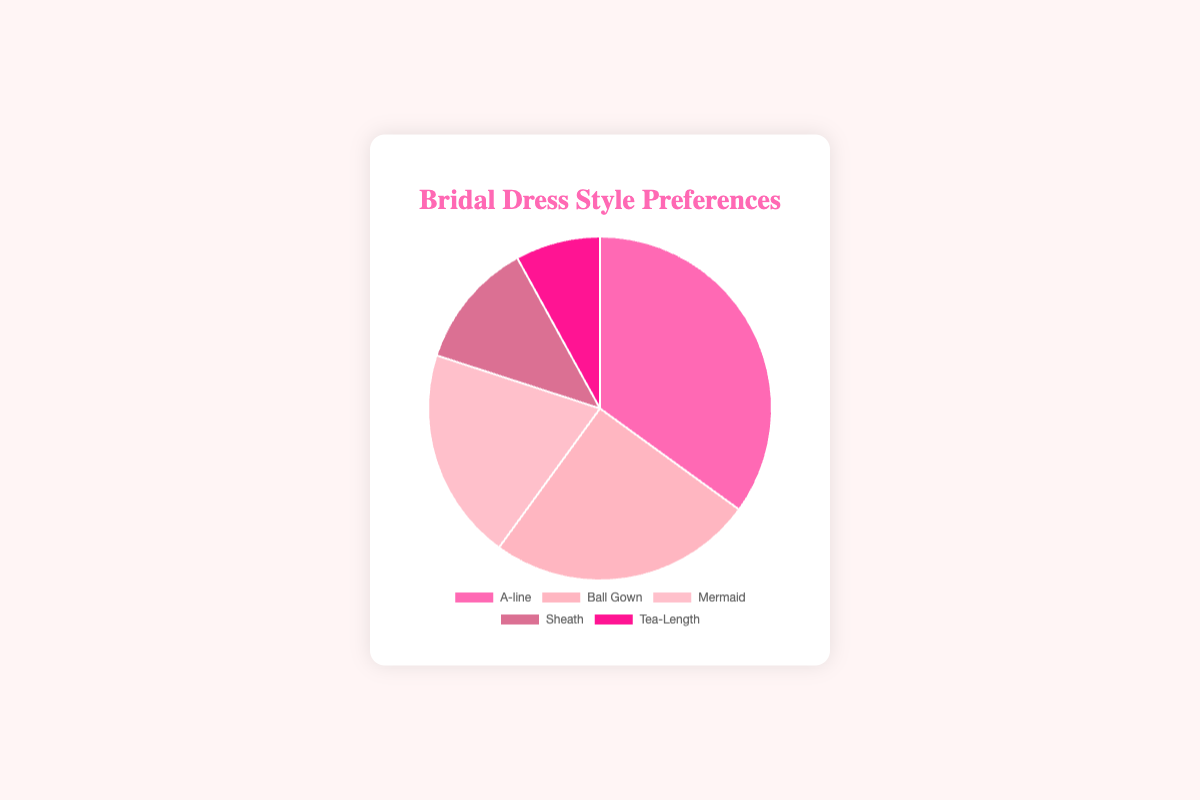Which dress style is preferred the most among brides? By looking at the pie chart, the A-line dress style has the largest section, indicating it is the most preferred.
Answer: A-line Which dress style is the least preferred among brides? By observing the smallest section of the pie chart, Tea-Length is the least preferred dress style.
Answer: Tea-Length How much more preferred is the A-line dress compared to the Mermaid dress? The A-line dress is preferred by 35% and the Mermaid dress by 20%. The difference between them is 35% - 20% = 15%.
Answer: 15% Calculate the total percentage of brides who prefer Ball Gown and Sheath styles combined. Ball Gown and Sheath dresses are preferred by 25% and 12% of brides, respectively. Adding these gives 25% + 12% = 37%.
Answer: 37% Is the Ball Gown dress style more preferred than the Mermaid dress style? The Ball Gown dress style is preferred by 25%, while the Mermaid style is preferred by 20%. Since 25% > 20%, the Ball Gown is more preferred.
Answer: Yes Which dress style has the second largest preference percentage? By examining the slices, the Ball Gown dress style has the second largest slice after A-line.
Answer: Ball Gown What is the combined preference percentage for the A-line, Ball Gown, and Tea-Length styles? A-line, Ball Gown, and Tea-Length are preferred by 35%, 25%, and 8% respectively. Adding these gives 35% + 25% + 8% = 68%.
Answer: 68% What percentage of brides prefer a Mermaid or Sheath dress? Mermaid and Sheath dresses are preferred by 20% and 12% respectively. Adding these gives 20% + 12% = 32%.
Answer: 32% Which dress style corresponds to the light pink color in the pie chart? By identifying the sections by color, the light pink section corresponds to the Ball Gown dress style.
Answer: Ball Gown 